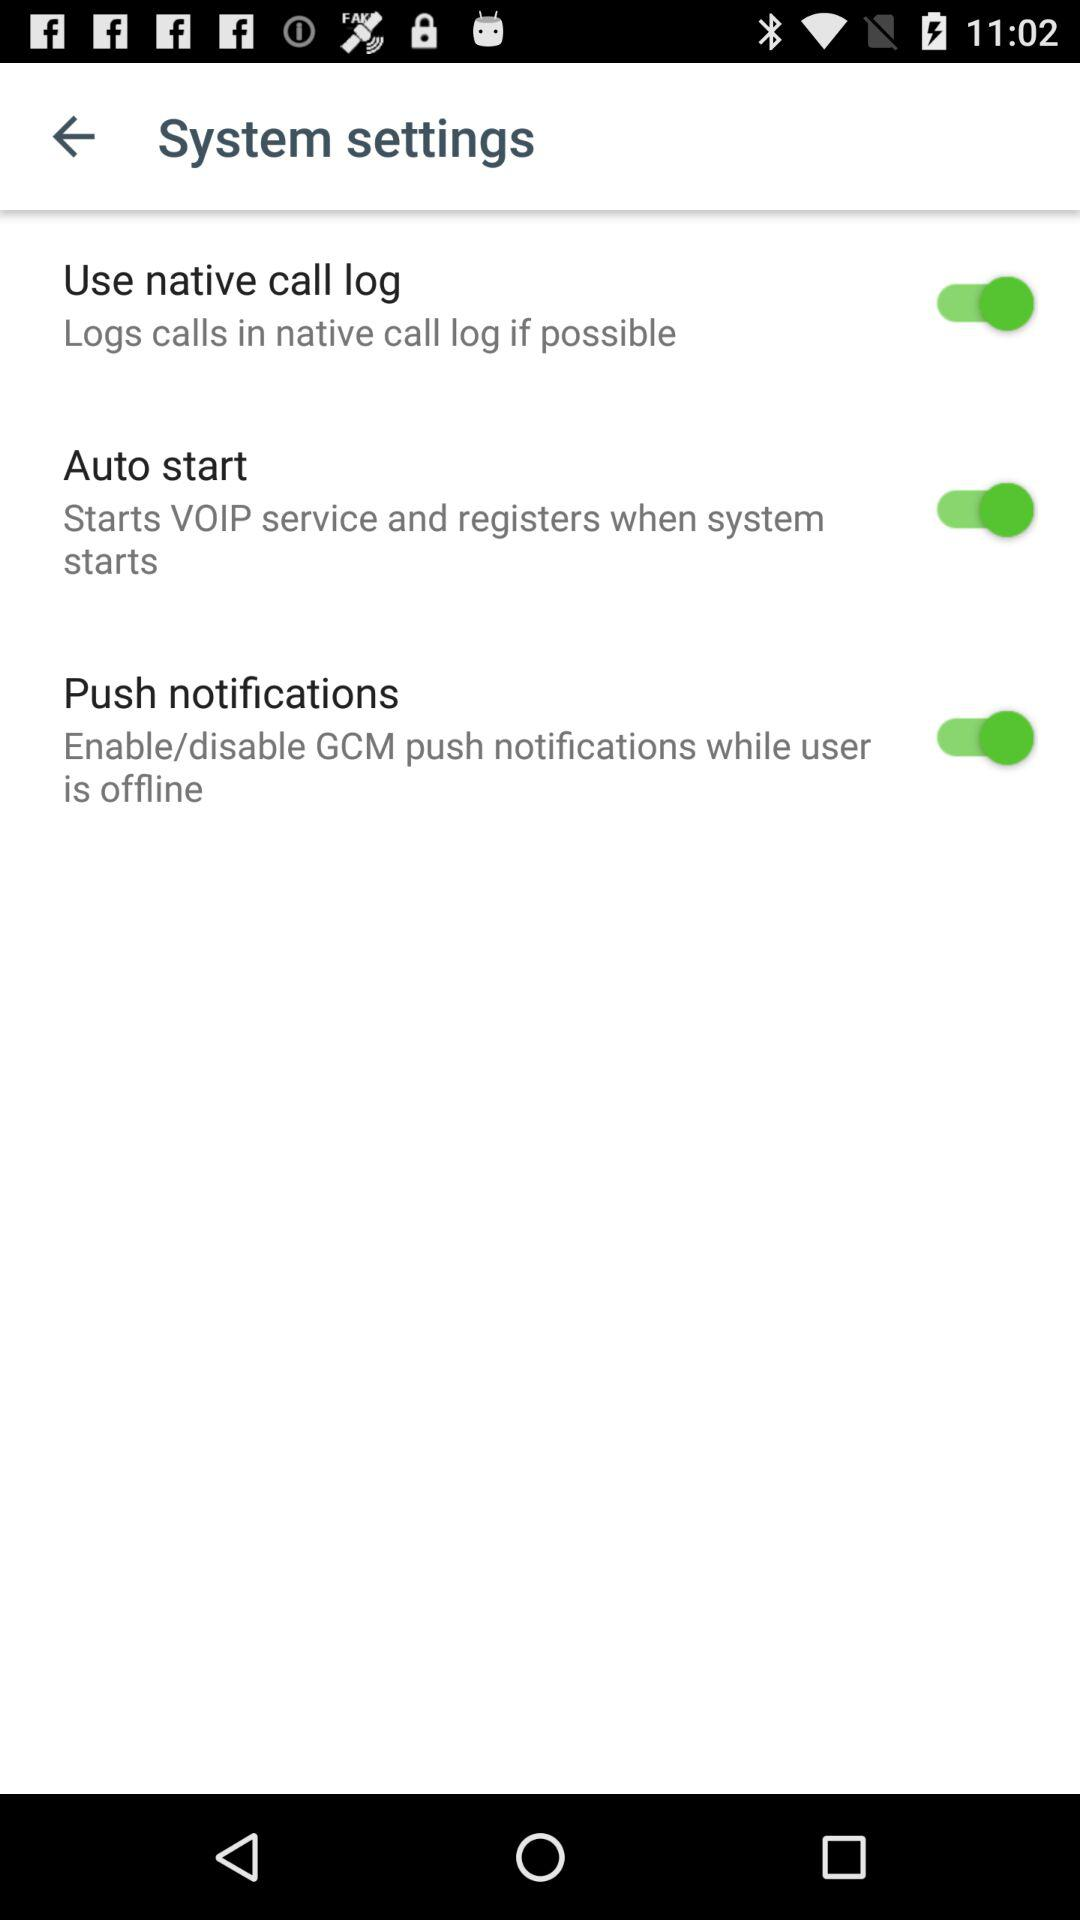What is the status of "Auto start"? The status of "Auto start" is "on". 